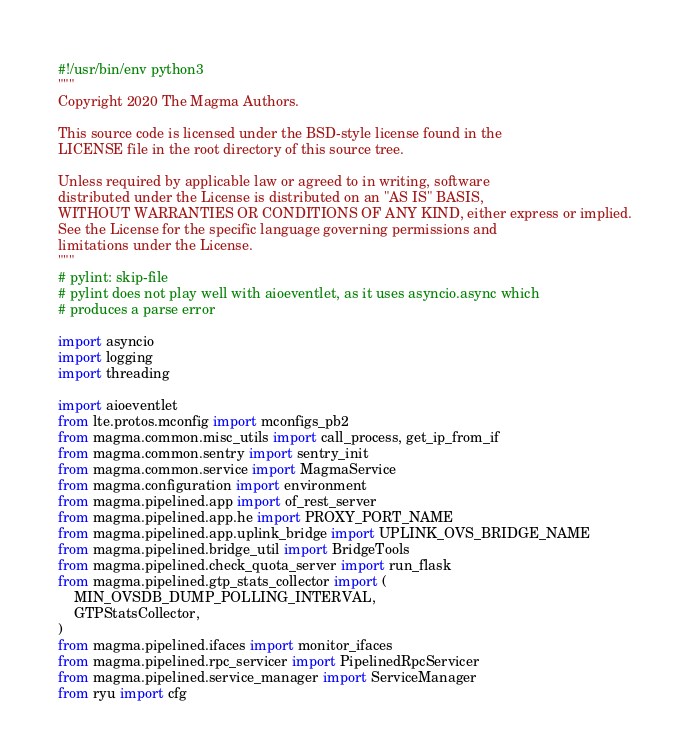Convert code to text. <code><loc_0><loc_0><loc_500><loc_500><_Python_>#!/usr/bin/env python3
"""
Copyright 2020 The Magma Authors.

This source code is licensed under the BSD-style license found in the
LICENSE file in the root directory of this source tree.

Unless required by applicable law or agreed to in writing, software
distributed under the License is distributed on an "AS IS" BASIS,
WITHOUT WARRANTIES OR CONDITIONS OF ANY KIND, either express or implied.
See the License for the specific language governing permissions and
limitations under the License.
"""
# pylint: skip-file
# pylint does not play well with aioeventlet, as it uses asyncio.async which
# produces a parse error

import asyncio
import logging
import threading

import aioeventlet
from lte.protos.mconfig import mconfigs_pb2
from magma.common.misc_utils import call_process, get_ip_from_if
from magma.common.sentry import sentry_init
from magma.common.service import MagmaService
from magma.configuration import environment
from magma.pipelined.app import of_rest_server
from magma.pipelined.app.he import PROXY_PORT_NAME
from magma.pipelined.app.uplink_bridge import UPLINK_OVS_BRIDGE_NAME
from magma.pipelined.bridge_util import BridgeTools
from magma.pipelined.check_quota_server import run_flask
from magma.pipelined.gtp_stats_collector import (
    MIN_OVSDB_DUMP_POLLING_INTERVAL,
    GTPStatsCollector,
)
from magma.pipelined.ifaces import monitor_ifaces
from magma.pipelined.rpc_servicer import PipelinedRpcServicer
from magma.pipelined.service_manager import ServiceManager
from ryu import cfg</code> 